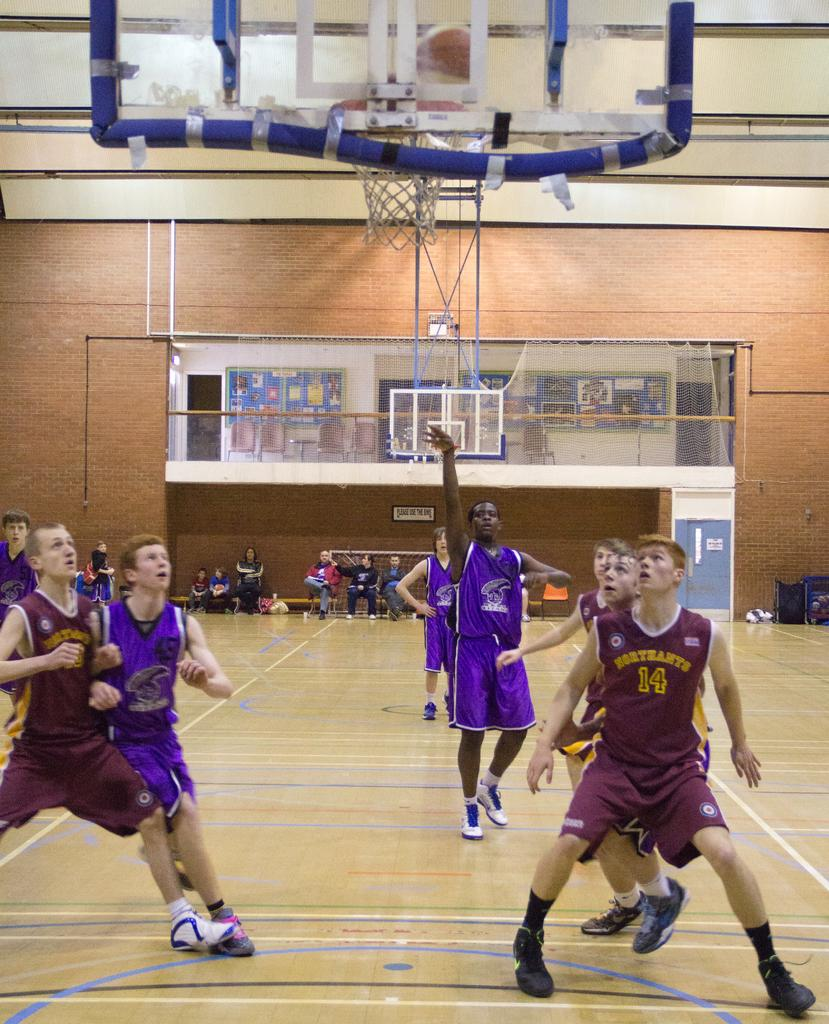Provide a one-sentence caption for the provided image. A boy from Northants boxes out while the other player shoots a free throw. 